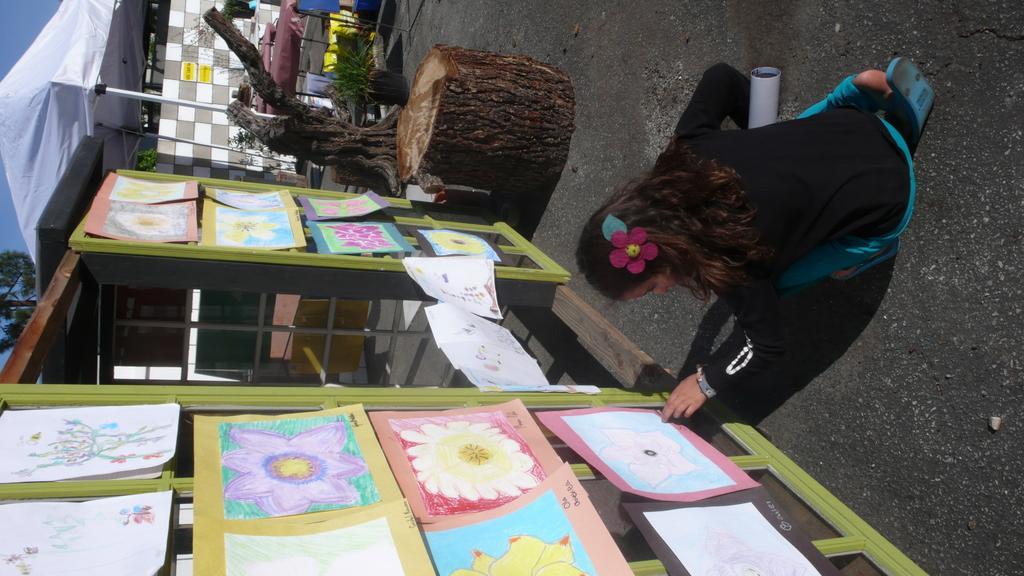Could you give a brief overview of what you see in this image? In this image I can see the person with black and white color dress. In-front of the person I can see the colorful papers attached to the glass. To the side I can see the trunk and the flowertots. I can also see the shed, tables, trees and the sky. 